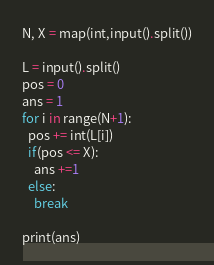<code> <loc_0><loc_0><loc_500><loc_500><_Python_>N, X = map(int,input().split())

L = input().split()
pos = 0
ans = 1
for i in range(N+1):
  pos += int(L[i])
  if(pos <= X):
    ans +=1
  else:
    break
  
print(ans)
</code> 